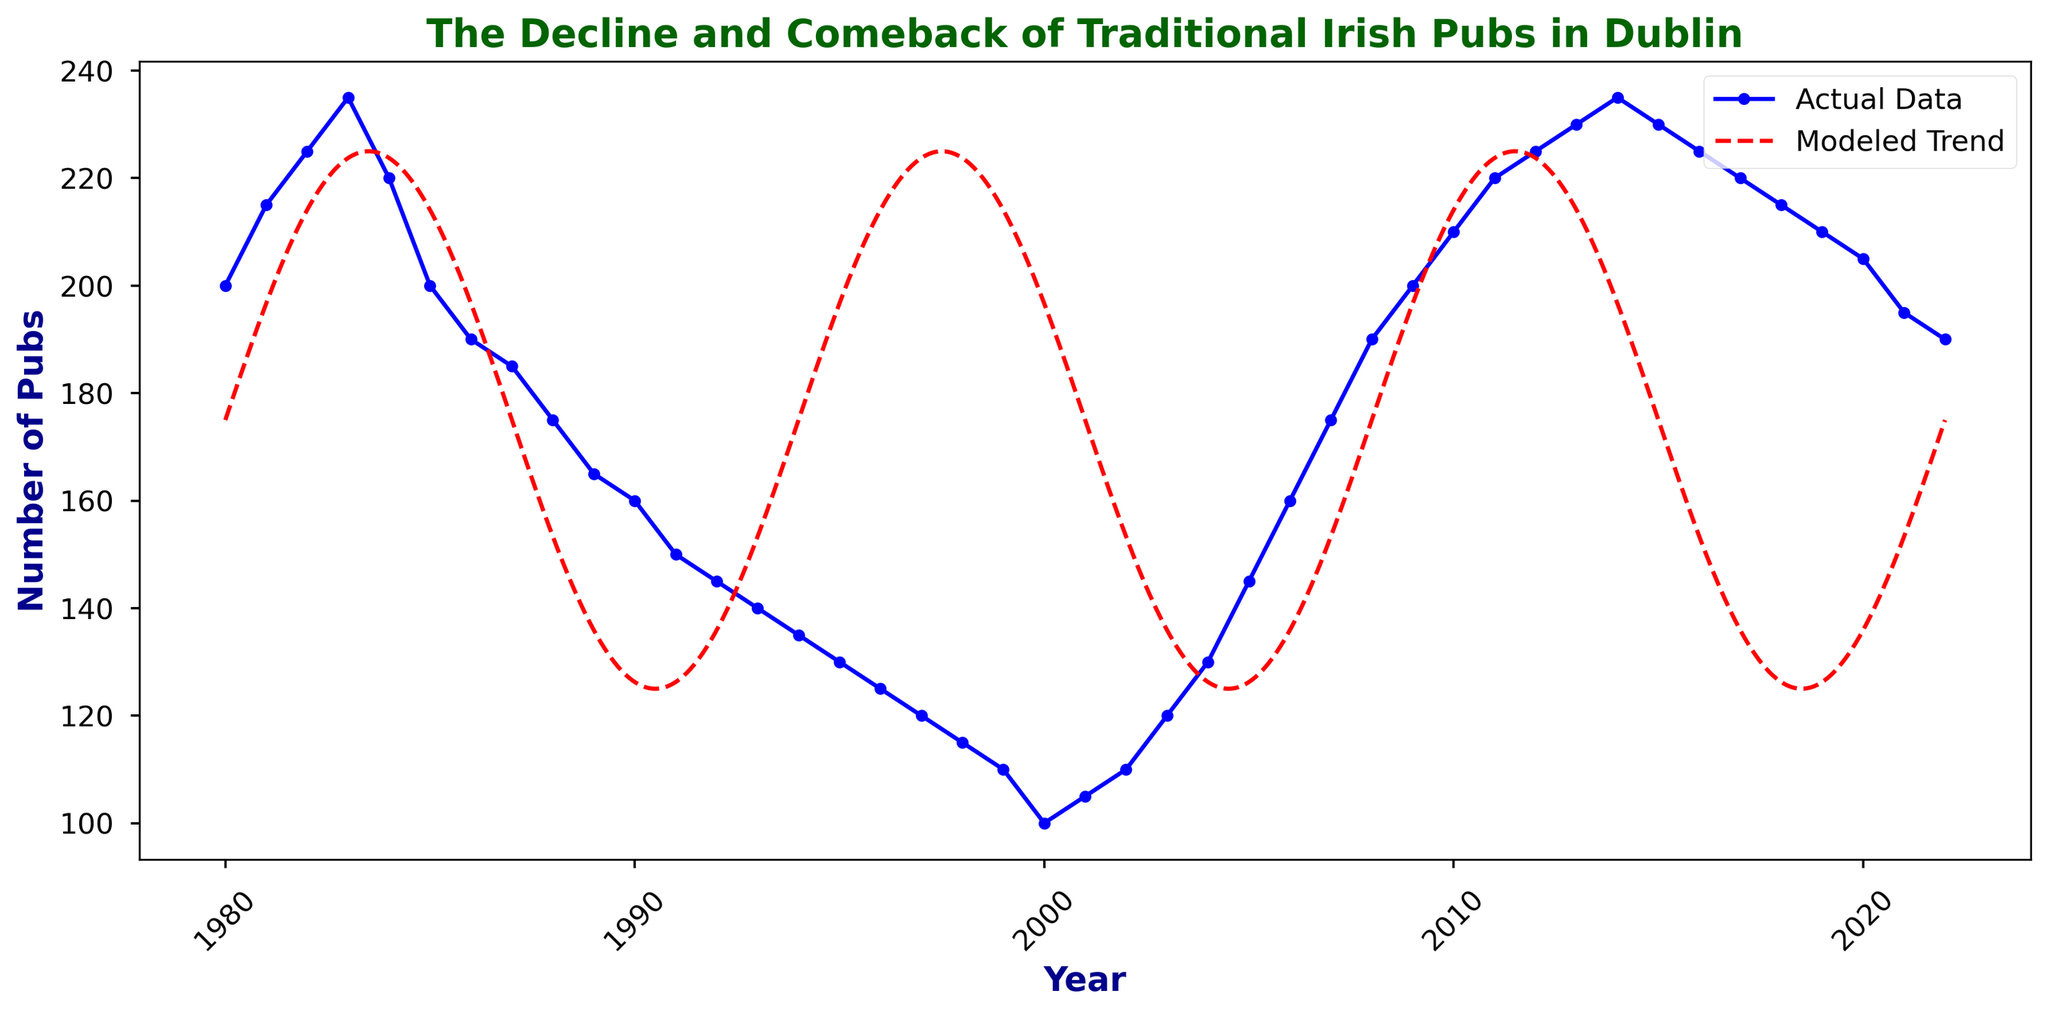Which year had the highest number of traditional Irish pubs in Dublin according to the actual data? The highest point in the actual data (blue line) represents the peak number of pubs. The data point at 1984 and from 2014 shows the highest count with 235 pubs.
Answer: 1984 and 2014 What is the difference in the number of pubs between 1983 and 1993 according to the actual data? Look at the data points for 1983 and 1993 on the blue line. The number of pubs in 1983 is 235, and in 1993, it is 140. The difference is 235 - 140.
Answer: 95 How does the actual number of pubs in 2003 compare to the modeled trend's prediction? Find the actual data point (blue line) and the modeled trend line (red dashed line) for the year 2003. The actual value is 120, and the modeled value is approximately around 180. The actual value is lower than the modeled value.
Answer: Lower What is the average number of pubs during the years 1980 to 1989 based on the actual data? Add the actual data points from 1980 to 1989 (200 + 215 + 225 + 235 + 220 + 200 + 190 + 185 + 175 + 165) and divide by the number of years (10). The sum is 2010. The average is 2010 / 10.
Answer: 201 Between which years does the actual data show the steepest decline in the number of pubs? Identify the steepest drop in the actual data (blue line). The steepest decline occurs from 1984 (235) to 1995 (130).
Answer: 1984 to 1995 Does the modeled trend predict a higher or lower number of pubs for 2022 compared to the actual data? Look at the end of the modeled trend line (red dashed line) and actual data (blue line) for the year 2022. The modeled trend is higher compared to the actual data.
Answer: Higher How many more pubs were there in the year 2000 compared to 2011 according to the actual data? Check the actual data points for 2000 and 2011. For 2000, the number is 100, and for 2011, it is 220. The difference is 220 - 100.
Answer: 120 Which color represents the actual data in the plot? Determine the color of the line marked as "Actual Data" in the legend. The actual data is represented by the blue line.
Answer: Blue 